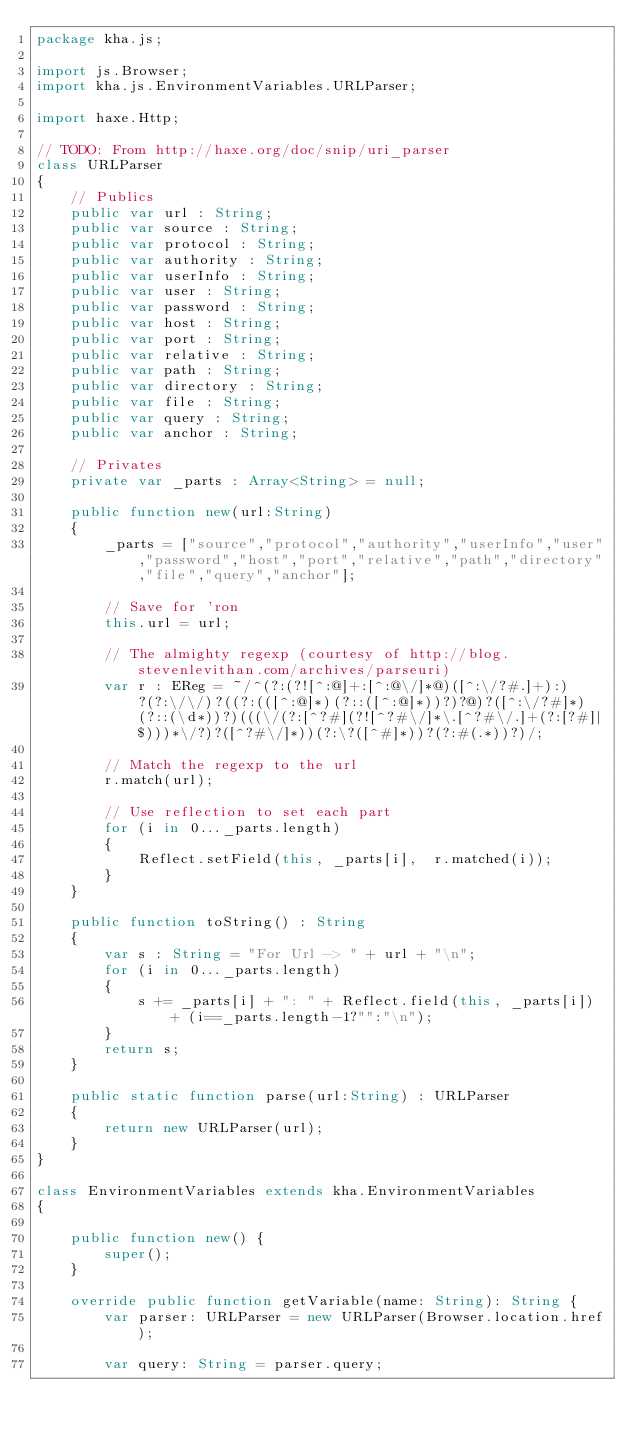<code> <loc_0><loc_0><loc_500><loc_500><_Haxe_>package kha.js;

import js.Browser;
import kha.js.EnvironmentVariables.URLParser;

import haxe.Http;

// TODO: From http://haxe.org/doc/snip/uri_parser
class URLParser
{
    // Publics
    public var url : String;
    public var source : String;
    public var protocol : String;
    public var authority : String;
    public var userInfo : String;
    public var user : String;
    public var password : String;
    public var host : String;
    public var port : String;
    public var relative : String;
    public var path : String;
    public var directory : String;
    public var file : String;
    public var query : String;
    public var anchor : String;
 
    // Privates
    private var _parts : Array<String> = null;
 
    public function new(url:String)
    {
		_parts = ["source","protocol","authority","userInfo","user","password","host","port","relative","path","directory","file","query","anchor"];
		
        // Save for 'ron
        this.url = url;
 
        // The almighty regexp (courtesy of http://blog.stevenlevithan.com/archives/parseuri)
        var r : EReg = ~/^(?:(?![^:@]+:[^:@\/]*@)([^:\/?#.]+):)?(?:\/\/)?((?:(([^:@]*)(?::([^:@]*))?)?@)?([^:\/?#]*)(?::(\d*))?)(((\/(?:[^?#](?![^?#\/]*\.[^?#\/.]+(?:[?#]|$)))*\/?)?([^?#\/]*))(?:\?([^#]*))?(?:#(.*))?)/;
 
        // Match the regexp to the url
        r.match(url);
 
        // Use reflection to set each part
        for (i in 0..._parts.length)
        {
            Reflect.setField(this, _parts[i],  r.matched(i));
        }
    }
 
    public function toString() : String
    {
        var s : String = "For Url -> " + url + "\n";
        for (i in 0..._parts.length)
        {
            s += _parts[i] + ": " + Reflect.field(this, _parts[i]) + (i==_parts.length-1?"":"\n");
        }
        return s;
    }
 
    public static function parse(url:String) : URLParser
    {
        return new URLParser(url);
    }
}

class EnvironmentVariables extends kha.EnvironmentVariables
{

	public function new() {
		super();
	}
	
	override public function getVariable(name: String): String {
		var parser: URLParser = new URLParser(Browser.location.href);
		
		var query: String = parser.query;
		</code> 